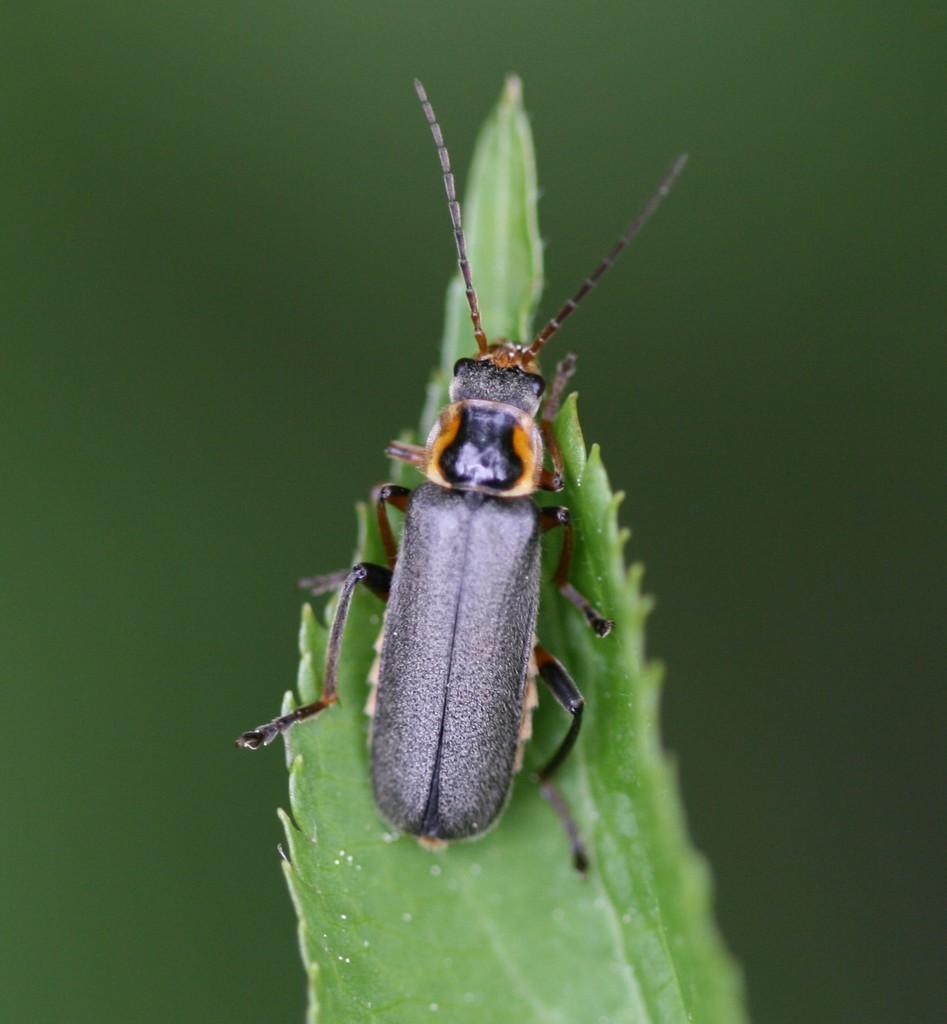What is present on the leaf in the image? There is an insect on the leaf in the image. What is the color of the background in the image? The background of the image is green. How many babies are visible in the image? There are no babies present in the image; it features an insect on a leaf with a green background. 